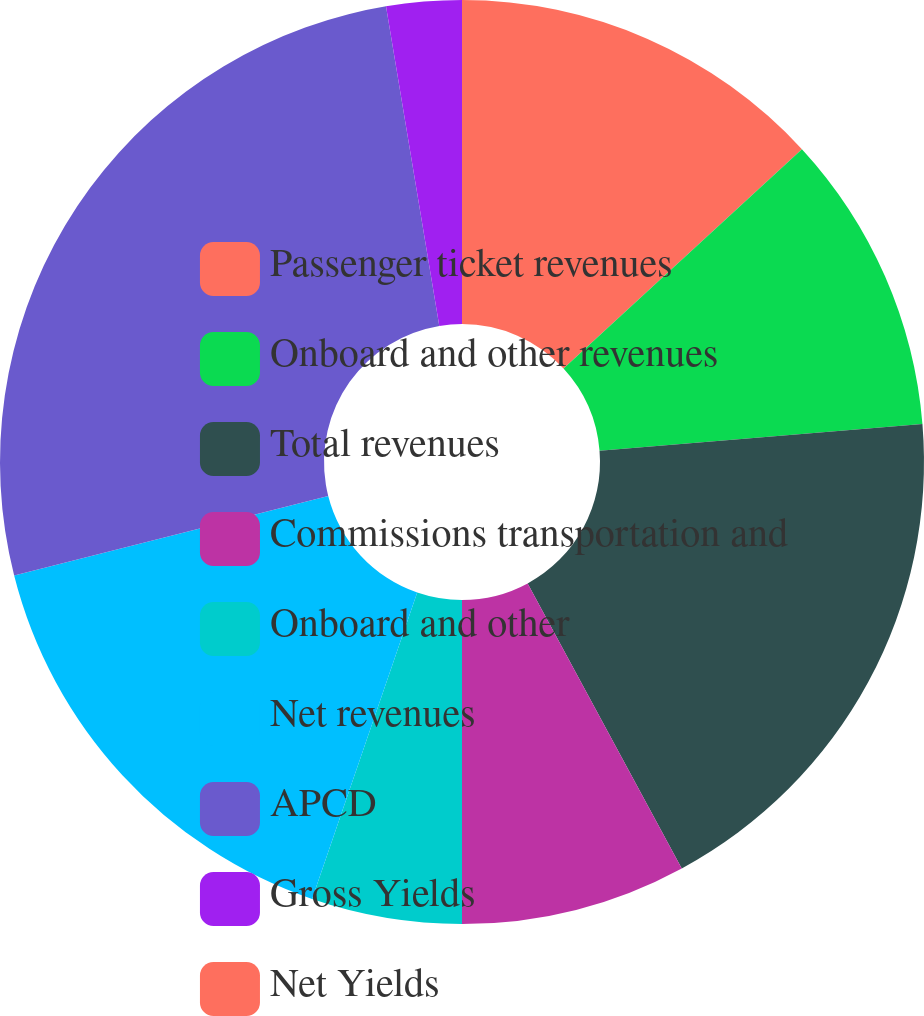Convert chart. <chart><loc_0><loc_0><loc_500><loc_500><pie_chart><fcel>Passenger ticket revenues<fcel>Onboard and other revenues<fcel>Total revenues<fcel>Commissions transportation and<fcel>Onboard and other<fcel>Net revenues<fcel>APCD<fcel>Gross Yields<fcel>Net Yields<nl><fcel>13.16%<fcel>10.53%<fcel>18.42%<fcel>7.89%<fcel>5.26%<fcel>15.79%<fcel>26.32%<fcel>2.63%<fcel>0.0%<nl></chart> 